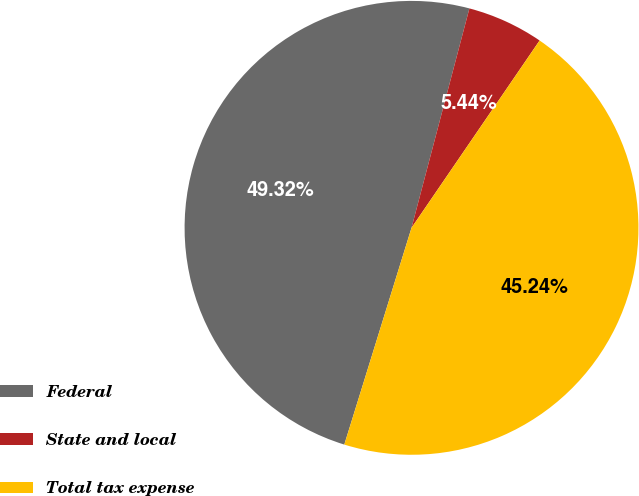Convert chart. <chart><loc_0><loc_0><loc_500><loc_500><pie_chart><fcel>Federal<fcel>State and local<fcel>Total tax expense<nl><fcel>49.32%<fcel>5.44%<fcel>45.24%<nl></chart> 